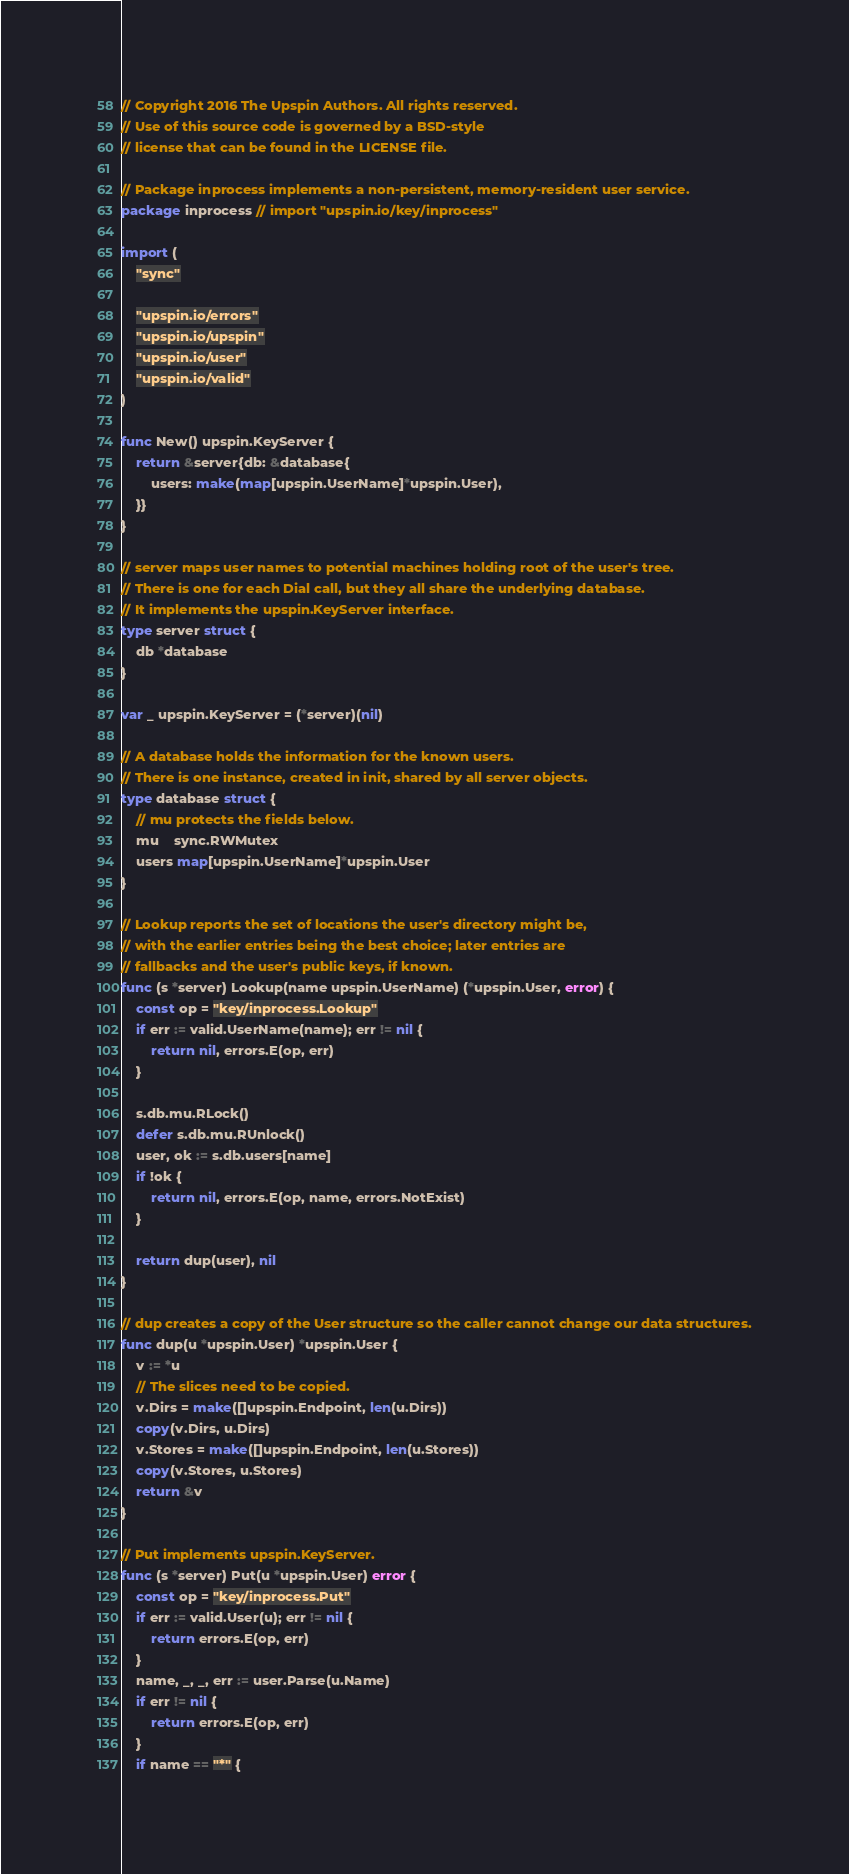Convert code to text. <code><loc_0><loc_0><loc_500><loc_500><_Go_>// Copyright 2016 The Upspin Authors. All rights reserved.
// Use of this source code is governed by a BSD-style
// license that can be found in the LICENSE file.

// Package inprocess implements a non-persistent, memory-resident user service.
package inprocess // import "upspin.io/key/inprocess"

import (
	"sync"

	"upspin.io/errors"
	"upspin.io/upspin"
	"upspin.io/user"
	"upspin.io/valid"
)

func New() upspin.KeyServer {
	return &server{db: &database{
		users: make(map[upspin.UserName]*upspin.User),
	}}
}

// server maps user names to potential machines holding root of the user's tree.
// There is one for each Dial call, but they all share the underlying database.
// It implements the upspin.KeyServer interface.
type server struct {
	db *database
}

var _ upspin.KeyServer = (*server)(nil)

// A database holds the information for the known users.
// There is one instance, created in init, shared by all server objects.
type database struct {
	// mu protects the fields below.
	mu    sync.RWMutex
	users map[upspin.UserName]*upspin.User
}

// Lookup reports the set of locations the user's directory might be,
// with the earlier entries being the best choice; later entries are
// fallbacks and the user's public keys, if known.
func (s *server) Lookup(name upspin.UserName) (*upspin.User, error) {
	const op = "key/inprocess.Lookup"
	if err := valid.UserName(name); err != nil {
		return nil, errors.E(op, err)
	}

	s.db.mu.RLock()
	defer s.db.mu.RUnlock()
	user, ok := s.db.users[name]
	if !ok {
		return nil, errors.E(op, name, errors.NotExist)
	}

	return dup(user), nil
}

// dup creates a copy of the User structure so the caller cannot change our data structures.
func dup(u *upspin.User) *upspin.User {
	v := *u
	// The slices need to be copied.
	v.Dirs = make([]upspin.Endpoint, len(u.Dirs))
	copy(v.Dirs, u.Dirs)
	v.Stores = make([]upspin.Endpoint, len(u.Stores))
	copy(v.Stores, u.Stores)
	return &v
}

// Put implements upspin.KeyServer.
func (s *server) Put(u *upspin.User) error {
	const op = "key/inprocess.Put"
	if err := valid.User(u); err != nil {
		return errors.E(op, err)
	}
	name, _, _, err := user.Parse(u.Name)
	if err != nil {
		return errors.E(op, err)
	}
	if name == "*" {</code> 